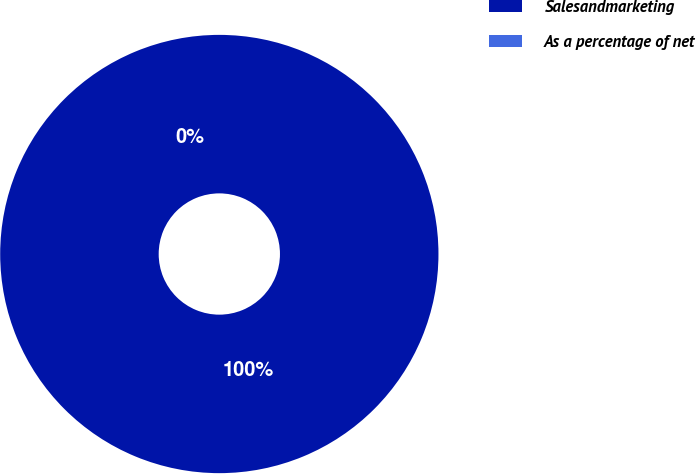Convert chart to OTSL. <chart><loc_0><loc_0><loc_500><loc_500><pie_chart><fcel>Salesandmarketing<fcel>As a percentage of net<nl><fcel>100.0%<fcel>0.0%<nl></chart> 